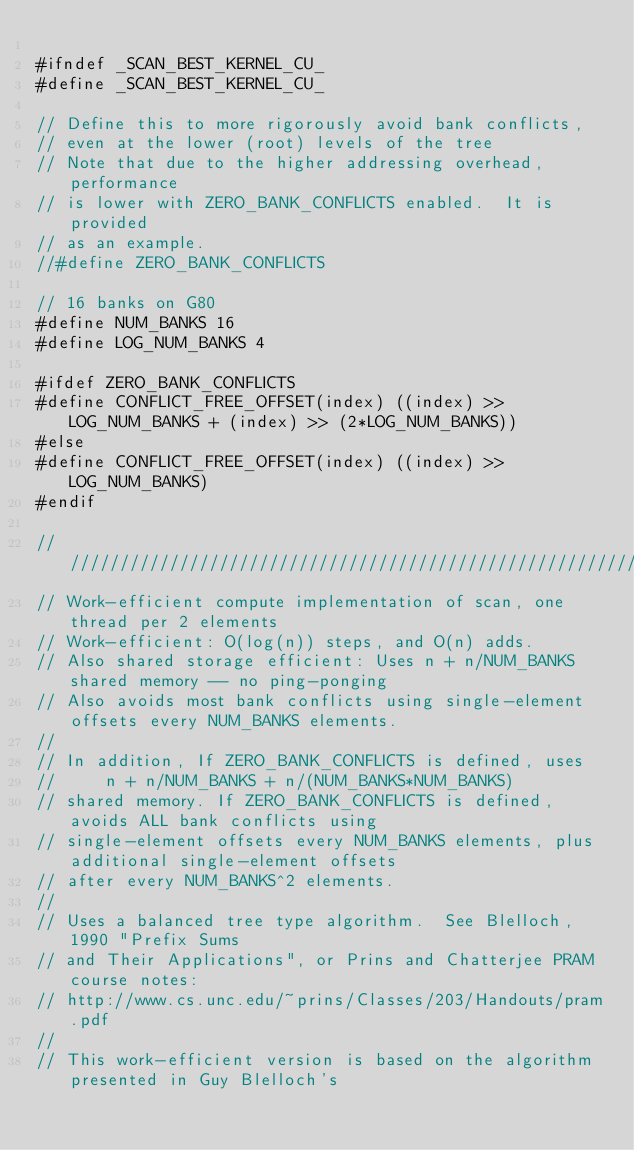<code> <loc_0><loc_0><loc_500><loc_500><_Cuda_>
#ifndef _SCAN_BEST_KERNEL_CU_
#define _SCAN_BEST_KERNEL_CU_

// Define this to more rigorously avoid bank conflicts, 
// even at the lower (root) levels of the tree
// Note that due to the higher addressing overhead, performance 
// is lower with ZERO_BANK_CONFLICTS enabled.  It is provided
// as an example.
//#define ZERO_BANK_CONFLICTS 

// 16 banks on G80
#define NUM_BANKS 16
#define LOG_NUM_BANKS 4

#ifdef ZERO_BANK_CONFLICTS
#define CONFLICT_FREE_OFFSET(index) ((index) >> LOG_NUM_BANKS + (index) >> (2*LOG_NUM_BANKS))
#else
#define CONFLICT_FREE_OFFSET(index) ((index) >> LOG_NUM_BANKS)
#endif

///////////////////////////////////////////////////////////////////////////////
// Work-efficient compute implementation of scan, one thread per 2 elements
// Work-efficient: O(log(n)) steps, and O(n) adds.
// Also shared storage efficient: Uses n + n/NUM_BANKS shared memory -- no ping-ponging
// Also avoids most bank conflicts using single-element offsets every NUM_BANKS elements.
//
// In addition, If ZERO_BANK_CONFLICTS is defined, uses 
//     n + n/NUM_BANKS + n/(NUM_BANKS*NUM_BANKS) 
// shared memory. If ZERO_BANK_CONFLICTS is defined, avoids ALL bank conflicts using 
// single-element offsets every NUM_BANKS elements, plus additional single-element offsets 
// after every NUM_BANKS^2 elements.
//
// Uses a balanced tree type algorithm.  See Blelloch, 1990 "Prefix Sums 
// and Their Applications", or Prins and Chatterjee PRAM course notes:
// http://www.cs.unc.edu/~prins/Classes/203/Handouts/pram.pdf
// 
// This work-efficient version is based on the algorithm presented in Guy Blelloch's</code> 